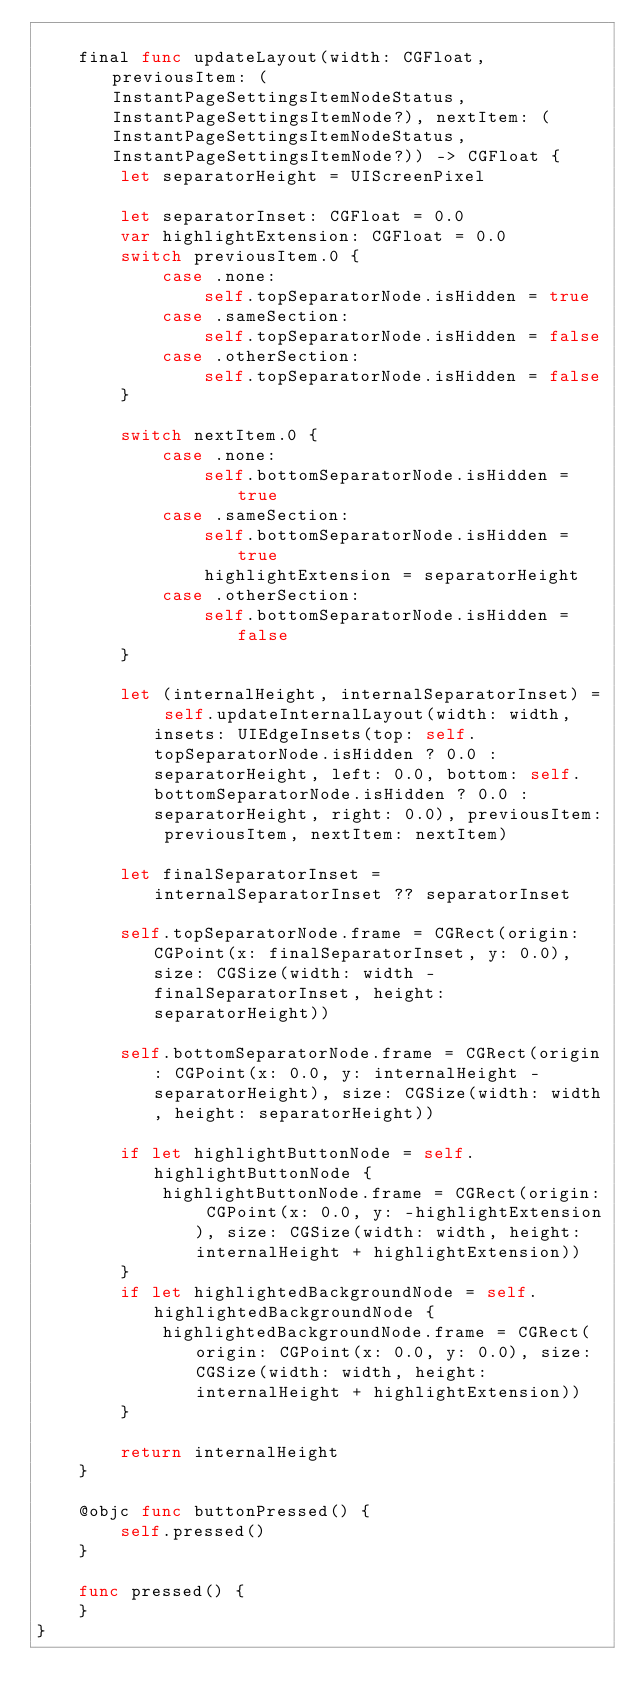Convert code to text. <code><loc_0><loc_0><loc_500><loc_500><_Swift_>    
    final func updateLayout(width: CGFloat, previousItem: (InstantPageSettingsItemNodeStatus, InstantPageSettingsItemNode?), nextItem: (InstantPageSettingsItemNodeStatus, InstantPageSettingsItemNode?)) -> CGFloat {
        let separatorHeight = UIScreenPixel
        
        let separatorInset: CGFloat = 0.0
        var highlightExtension: CGFloat = 0.0
        switch previousItem.0 {
            case .none:
                self.topSeparatorNode.isHidden = true
            case .sameSection:
                self.topSeparatorNode.isHidden = false
            case .otherSection:
                self.topSeparatorNode.isHidden = false
        }
        
        switch nextItem.0 {
            case .none:
                self.bottomSeparatorNode.isHidden = true
            case .sameSection:
                self.bottomSeparatorNode.isHidden = true
                highlightExtension = separatorHeight
            case .otherSection:
                self.bottomSeparatorNode.isHidden = false
        }
        
        let (internalHeight, internalSeparatorInset) = self.updateInternalLayout(width: width, insets: UIEdgeInsets(top: self.topSeparatorNode.isHidden ? 0.0 : separatorHeight, left: 0.0, bottom: self.bottomSeparatorNode.isHidden ? 0.0 : separatorHeight, right: 0.0), previousItem: previousItem, nextItem: nextItem)
        
        let finalSeparatorInset = internalSeparatorInset ?? separatorInset
        
        self.topSeparatorNode.frame = CGRect(origin: CGPoint(x: finalSeparatorInset, y: 0.0), size: CGSize(width: width - finalSeparatorInset, height: separatorHeight))
        
        self.bottomSeparatorNode.frame = CGRect(origin: CGPoint(x: 0.0, y: internalHeight - separatorHeight), size: CGSize(width: width, height: separatorHeight))
        
        if let highlightButtonNode = self.highlightButtonNode {
            highlightButtonNode.frame = CGRect(origin: CGPoint(x: 0.0, y: -highlightExtension), size: CGSize(width: width, height: internalHeight + highlightExtension))
        }
        if let highlightedBackgroundNode = self.highlightedBackgroundNode {
            highlightedBackgroundNode.frame = CGRect(origin: CGPoint(x: 0.0, y: 0.0), size: CGSize(width: width, height: internalHeight + highlightExtension))
        }
        
        return internalHeight
    }
    
    @objc func buttonPressed() {
        self.pressed()
    }
    
    func pressed() {
    }
}
</code> 